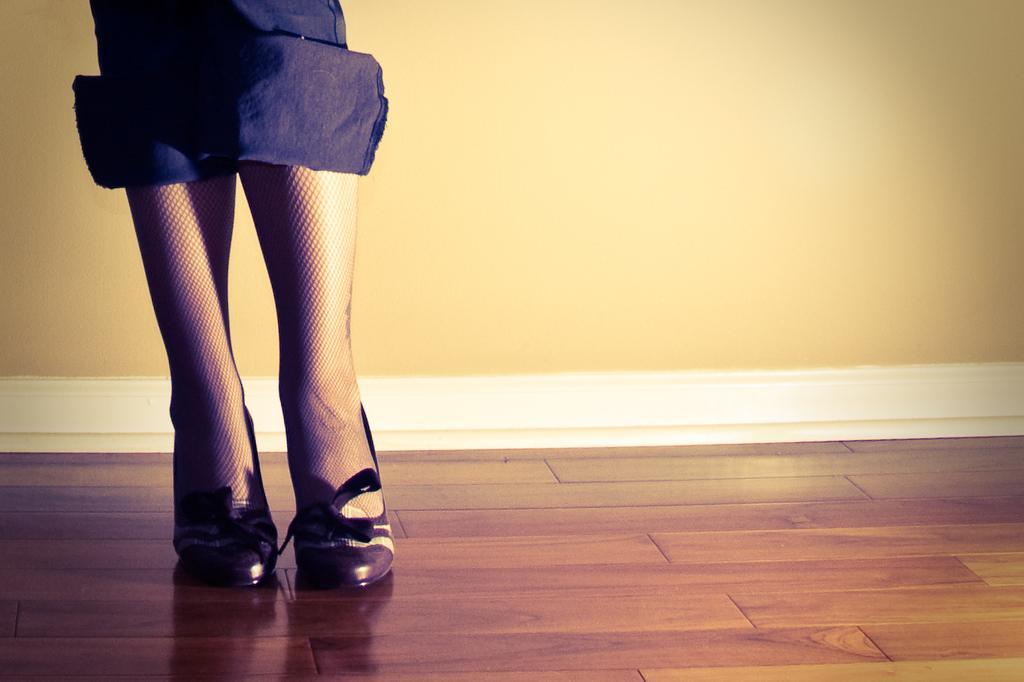Describe this image in one or two sentences. On the left side of this image I can see a person's legs wearing blue color trouser and shoes. This person is standing on the floor. In the background there is a wall. 